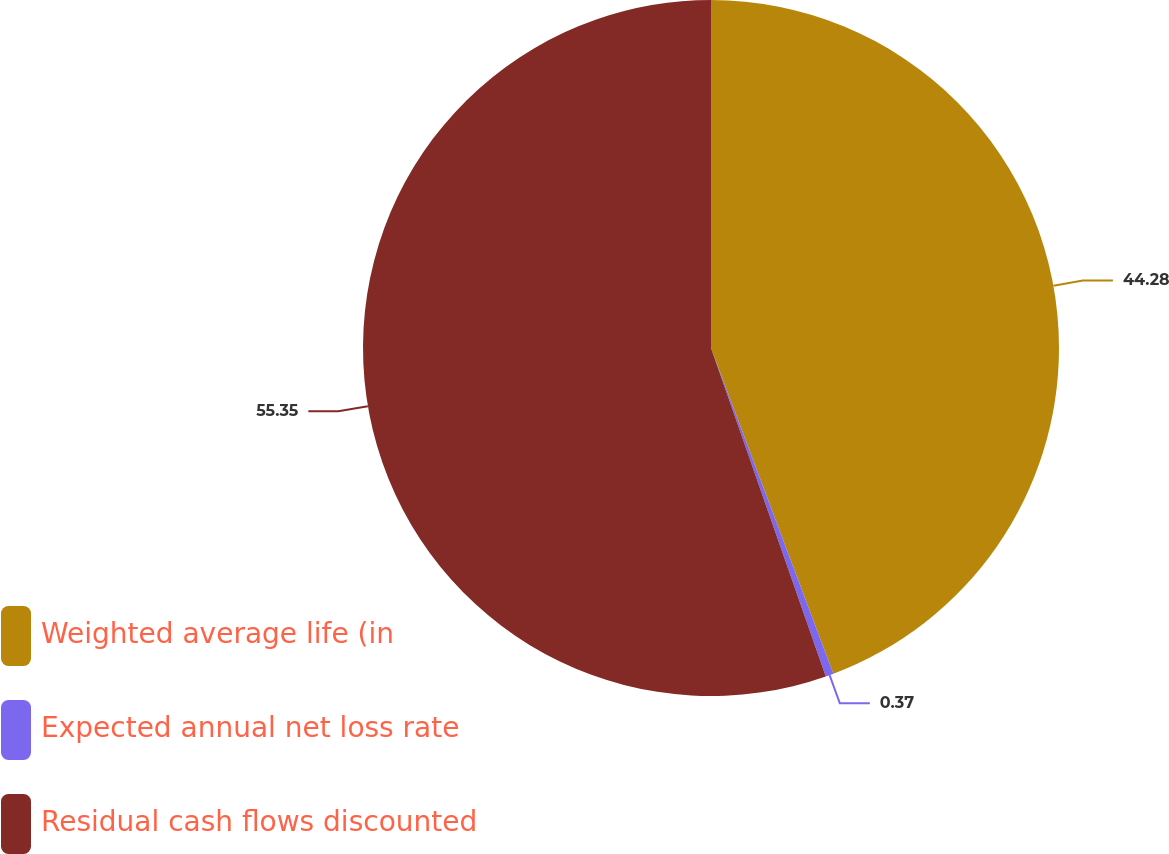Convert chart to OTSL. <chart><loc_0><loc_0><loc_500><loc_500><pie_chart><fcel>Weighted average life (in<fcel>Expected annual net loss rate<fcel>Residual cash flows discounted<nl><fcel>44.28%<fcel>0.37%<fcel>55.35%<nl></chart> 